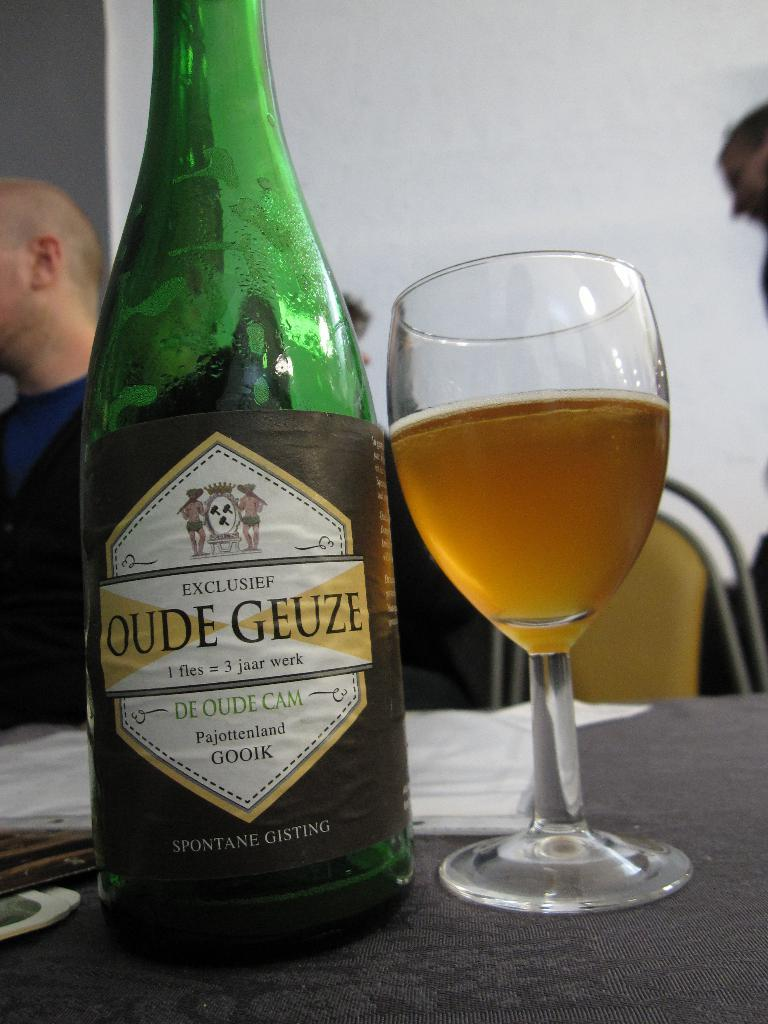<image>
Describe the image concisely. A green bottle of wine that says Oude Geuze is by a full wine glass. 